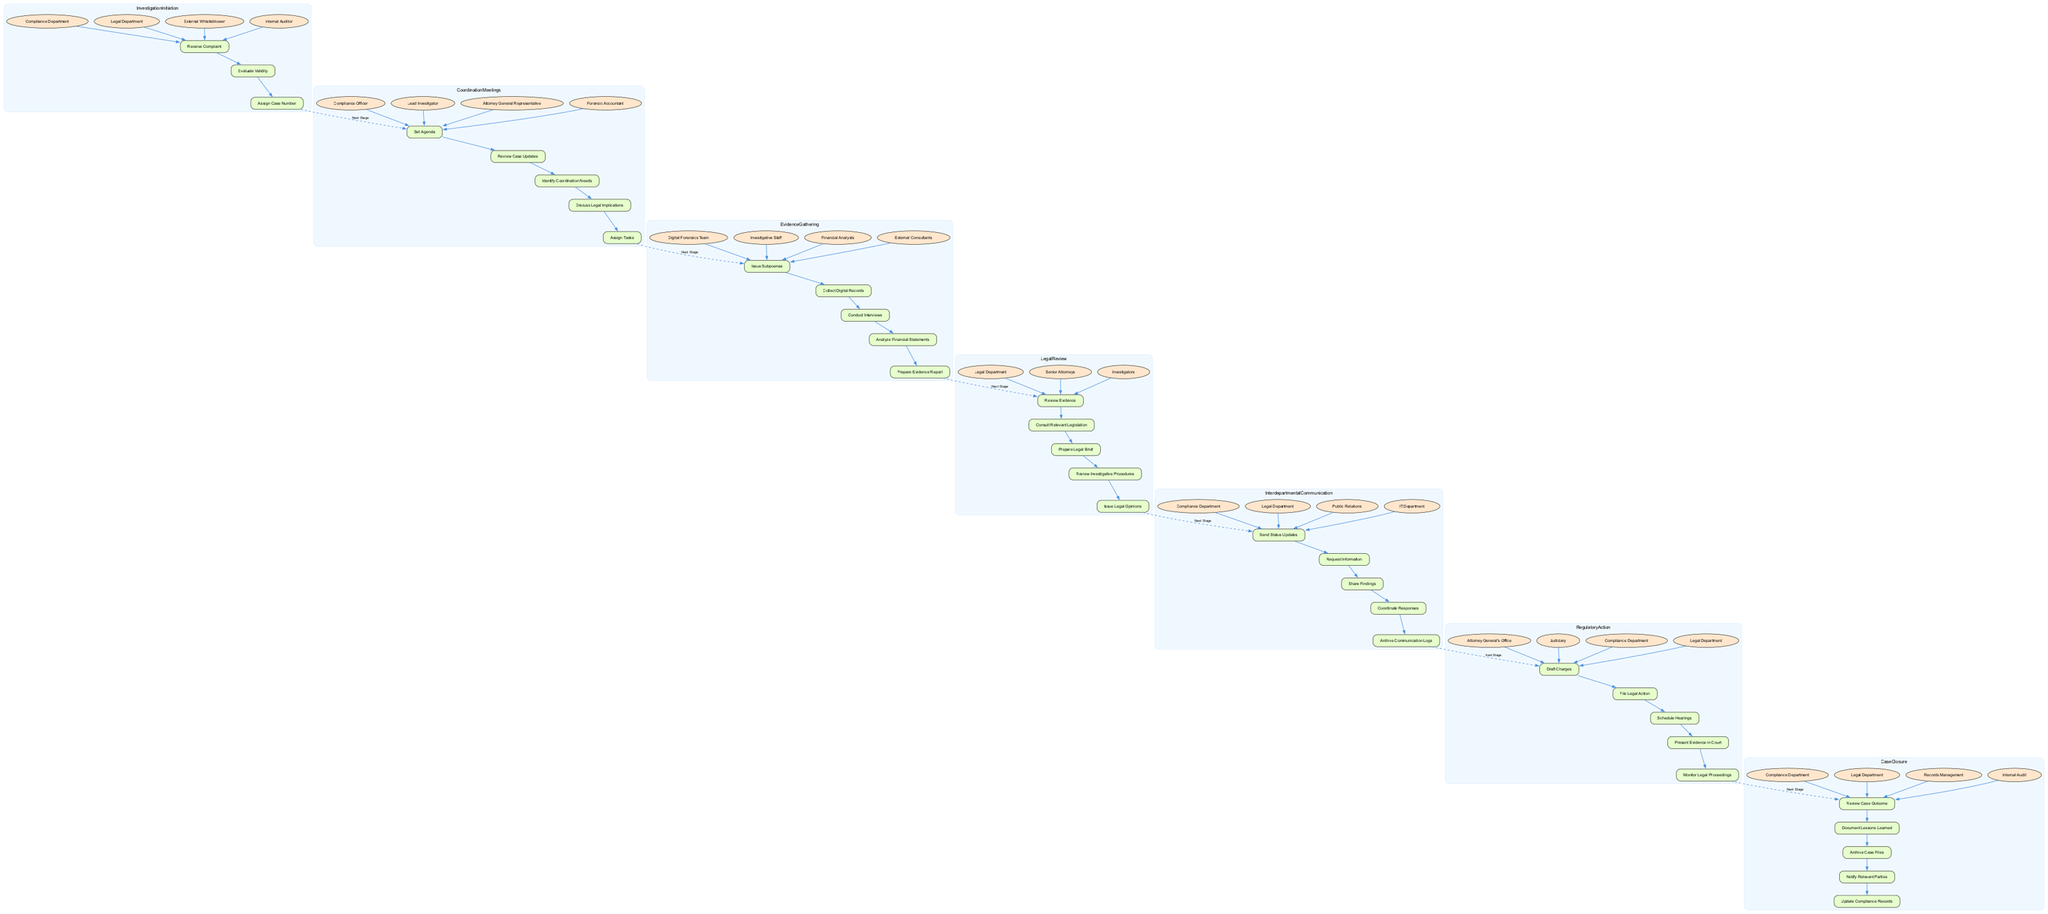What stage involves the Compliance Department, Legal Department, and Internal Auditor? The diagram shows that the "Investigation Initiation" stage involves these entities, indicating they play a role in receiving complaints, evaluating validity, and assigning case numbers.
Answer: Investigation Initiation How many actions are outlined in the Legal Review stage? By examining the "Legal Review" section in the diagram, we can count five specific actions defined there, namely: Review Evidence, Consult Relevant Legislation, Prepare Legal Brief, Review Investigative Procedures, and Issue Legal Opinions.
Answer: Five Which action is the last in the Evidence Gathering stage? Reviewing the "Evidence Gathering" section, the sequence of actions shows that "Prepare Evidence Report" is the last action listed, following the others in their designated order.
Answer: Prepare Evidence Report What is the direct next stage after Coordination Meetings? The flow from "Coordination Meetings" leads directly to "Evidence Gathering," as depicted by the dashed line connecting their last action to the first action of the next stage.
Answer: Evidence Gathering Which entities are involved in the Case Closure process? In the "Case Closure" section, the diagram identifies four entities involved, specifically the Compliance Department, Legal Department, Records Management, and Internal Audit.
Answer: Compliance Department, Legal Department, Records Management, Internal Audit What actions lead to filing legal action against a company? To answer this, we look at the "Regulatory Action" stage, which highlights several actions culminating with "File Legal Action," preceded by drafting charges and scheduling hearings.
Answer: Draft Charges, File Legal Action Which two departments are part of the Interdepartmental Communication action? The "Interdepartmental Communication" stage includes the Compliance Department and Legal Department among the entities involved, reflecting their collaboration during the investigation.
Answer: Compliance Department, Legal Department What is the first action in the Investigation Initiation stage? According to the "Investigation Initiation" section, the first action listed is "Receive Complaint," signifying the starting point of the investigation process.
Answer: Receive Complaint How many entities are involved in the Coordination Meetings? In reviewing the "Coordination Meetings" part of the diagram, there are four entities indicated: Compliance Officer, Lead Investigator, Attorney General Representative, and Forensic Accountant.
Answer: Four 